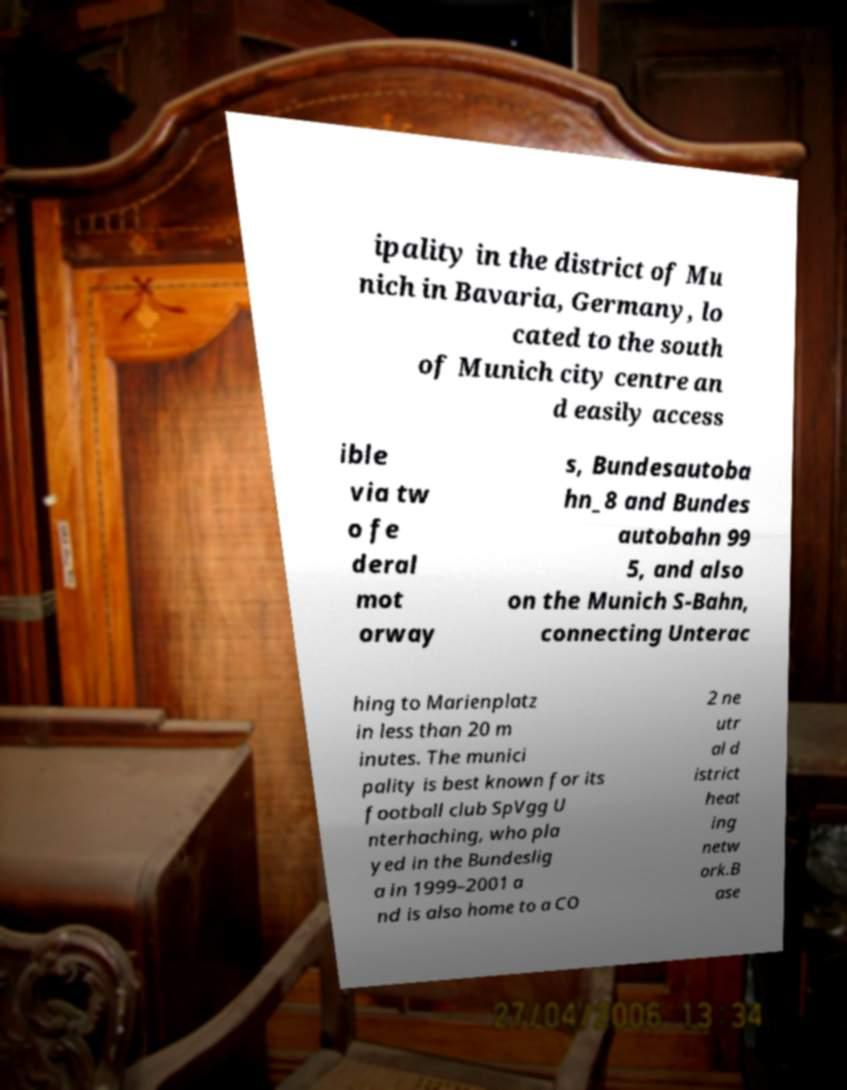Please identify and transcribe the text found in this image. ipality in the district of Mu nich in Bavaria, Germany, lo cated to the south of Munich city centre an d easily access ible via tw o fe deral mot orway s, Bundesautoba hn_8 and Bundes autobahn 99 5, and also on the Munich S-Bahn, connecting Unterac hing to Marienplatz in less than 20 m inutes. The munici pality is best known for its football club SpVgg U nterhaching, who pla yed in the Bundeslig a in 1999–2001 a nd is also home to a CO 2 ne utr al d istrict heat ing netw ork.B ase 